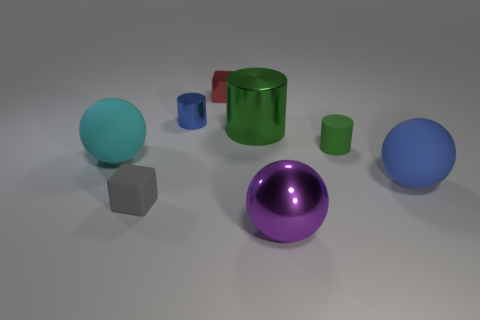If these objects were part of a collection, what theme do you think they would represent? If these objects were part of a collection, they might represent a theme of 'geometric shapes and colors.' The collection showcases a variety of shapes, such as spheres, cylinders, and a cube, each in different colors, which could be an exploration of how color and form interact in a controlled environment. 